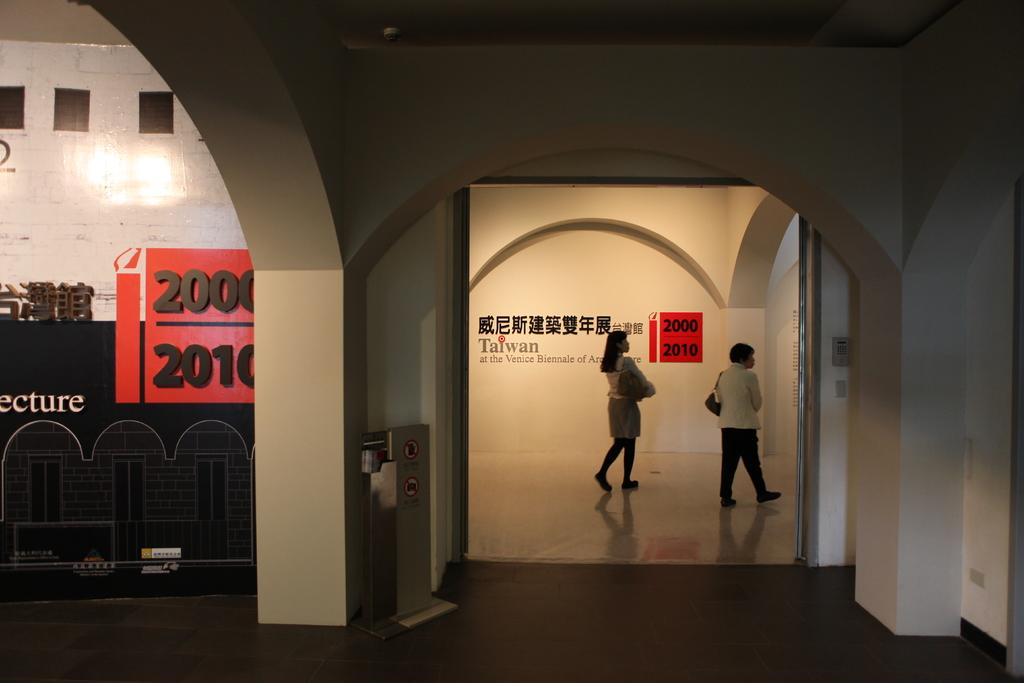What type of structure can be seen in the image? There is a wall in the image. What is hanging on the wall in the image? There is a banner in the image. What is located near the wall in the image? There is a dustbin in the image. What are the two people in the image doing? Two people are walking in the image. How many clovers are growing on the wall in the image? There are no clovers present in the image; it features a wall, a banner, a dustbin, and two people walking. What type of gardening tool is being used by the people in the image? There is no gardening tool visible in the image; the two people are simply walking. 